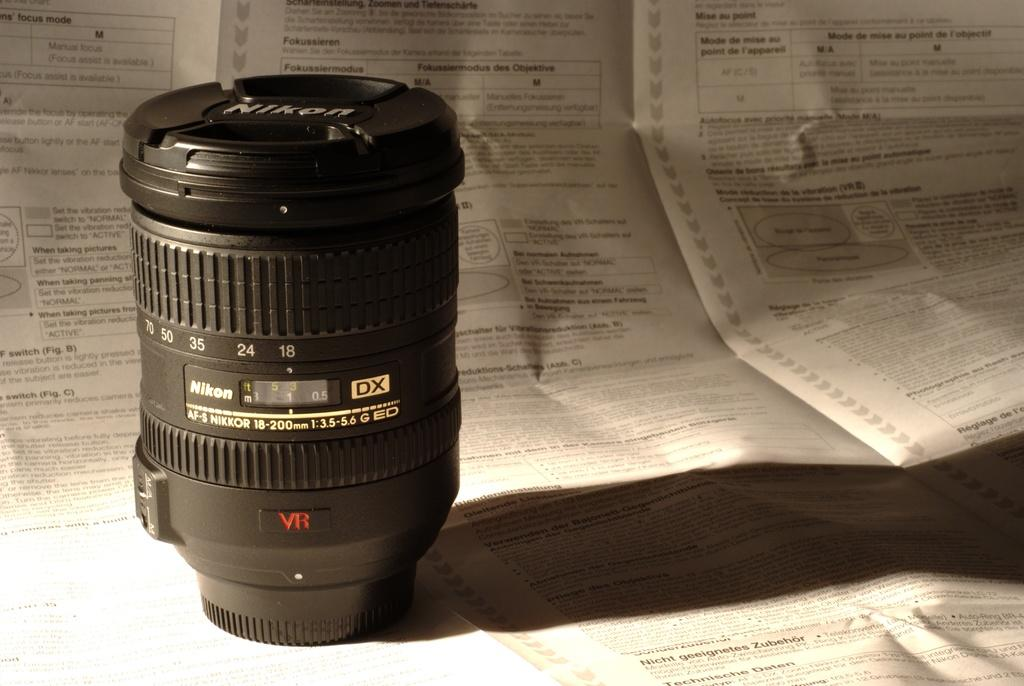What is the main subject of the image? The main subject of the image is a camera lens. Where is the camera lens located in the image? The camera lens is on a paper. What type of zinc is used to coat the camera lens in the image? There is no mention of zinc or any coating on the camera lens in the image. Can you see any army personnel in the image? There is no army personnel or any military-related elements present in the image. 